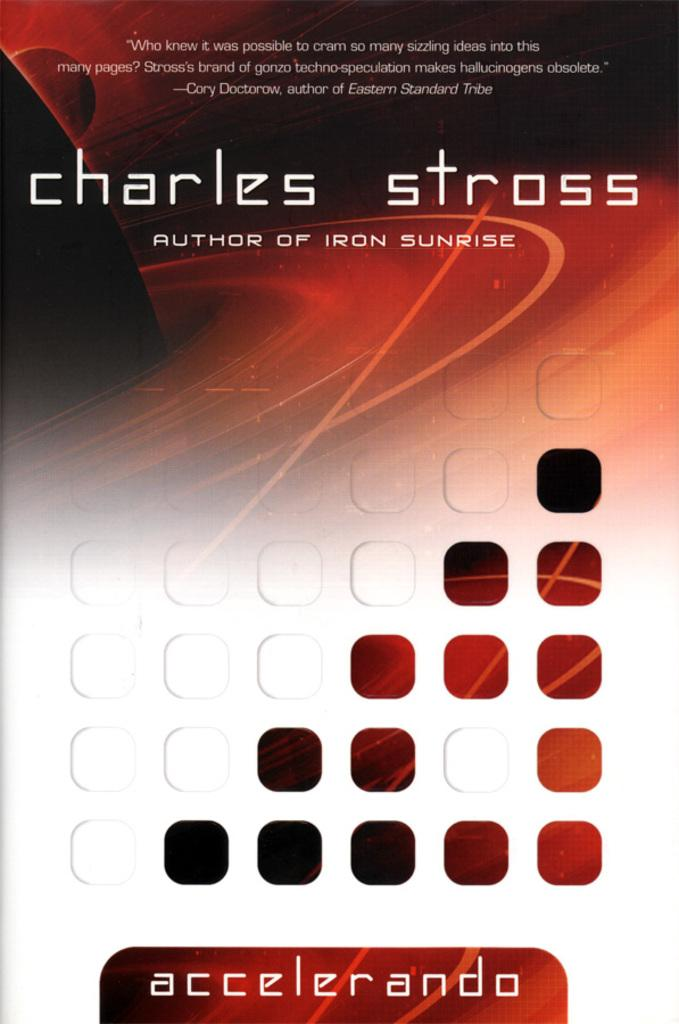<image>
Provide a brief description of the given image. a charles stross item that is above the accelerando 